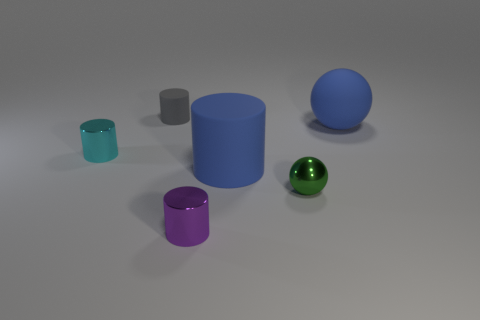Subtract all large blue matte cylinders. How many cylinders are left? 3 Subtract all green balls. How many balls are left? 1 Add 1 big red matte cubes. How many objects exist? 7 Subtract all cylinders. How many objects are left? 2 Subtract 1 spheres. How many spheres are left? 1 Subtract all blue spheres. Subtract all blue blocks. How many spheres are left? 1 Subtract all yellow blocks. How many red cylinders are left? 0 Subtract all big blue rubber things. Subtract all tiny gray cylinders. How many objects are left? 3 Add 5 small green balls. How many small green balls are left? 6 Add 5 cyan metal things. How many cyan metal things exist? 6 